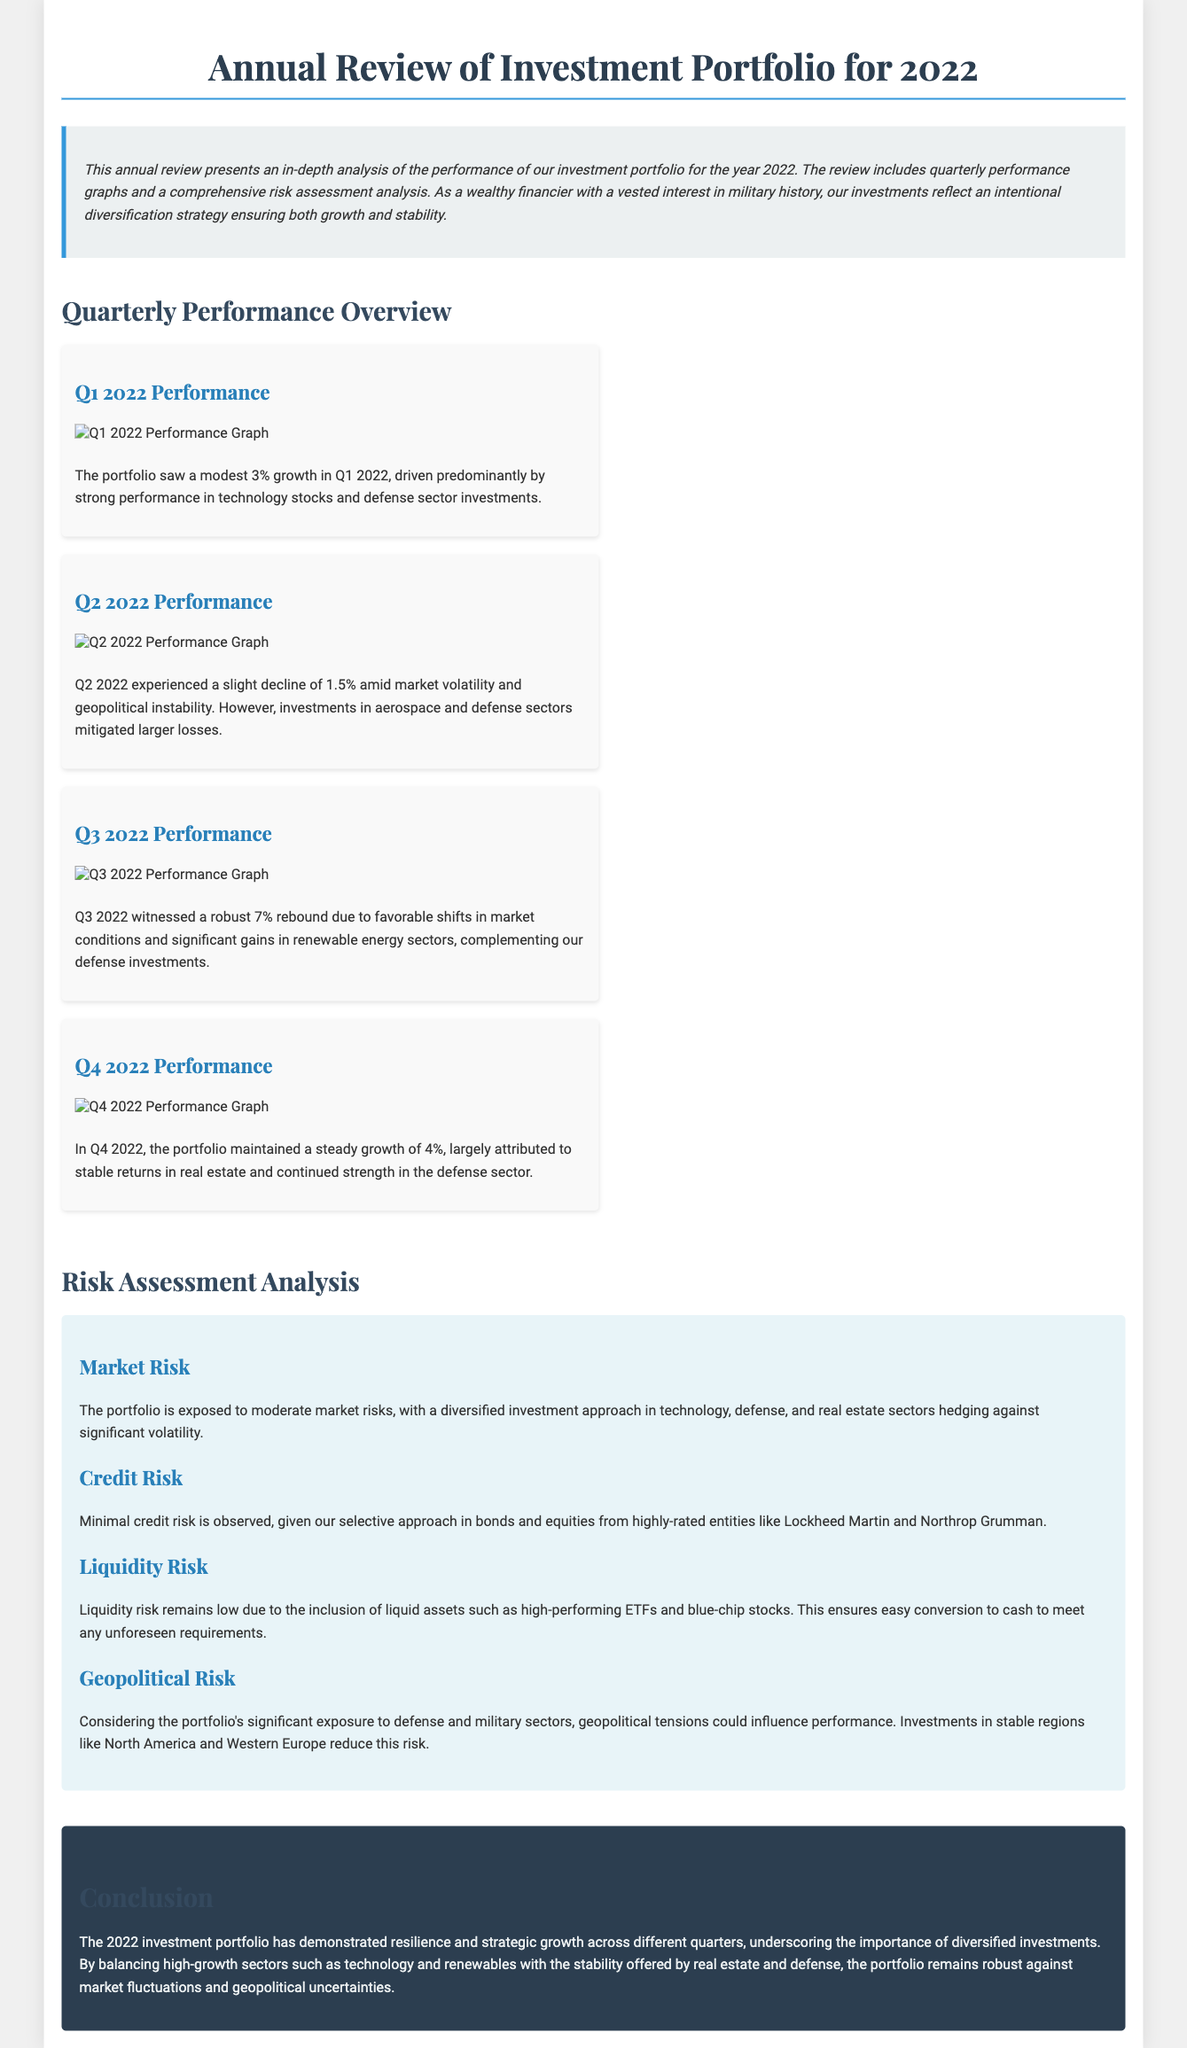What was the Q1 2022 growth percentage? The Q1 2022 performance showed a modest growth of 3%.
Answer: 3% What sectors contributed to Q2 2022 performance? The Q2 2022 performance was impacted by market volatility, but investments in aerospace and defense sectors mitigated losses.
Answer: Aerospace and defense What is the risk level associated with credit risk in the portfolio? The document states that minimal credit risk is observed due to a selective investment approach.
Answer: Minimal What was the percentage change in Q3 2022? Q3 2022 witnessed a robust gain of 7%.
Answer: 7% How much did the portfolio grow in Q4 2022? The portfolio maintained a steady growth of 4% in Q4 2022.
Answer: 4% Which investment sectors are mentioned as hedging against volatility? The portfolio is diversified into technology, defense, and real estate sectors, which hedge against significant volatility.
Answer: Technology, defense, and real estate What main risk type does geopolitical tension affect? Geopolitical tensions could influence the performance of the portfolio specifically in the defense and military sectors.
Answer: Performance What was the performance of the portfolio in Q2 2022? The portfolio experienced a slight decline of 1.5% amid market volatility.
Answer: Decline of 1.5% 